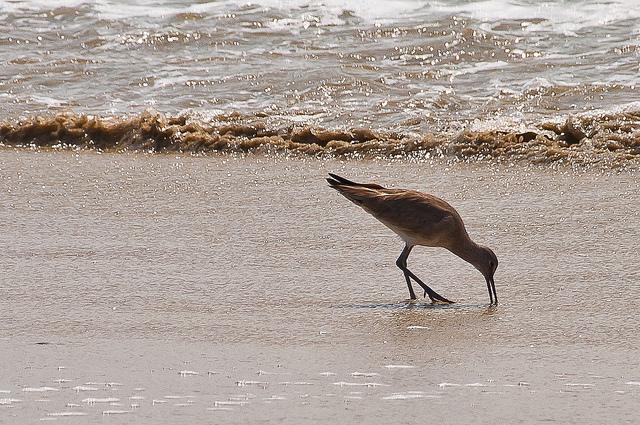Will the tide come close to the bird?
Keep it brief. Yes. What is the bird looking for?
Keep it brief. Food. What sort of bird is this?
Concise answer only. Seagull. 